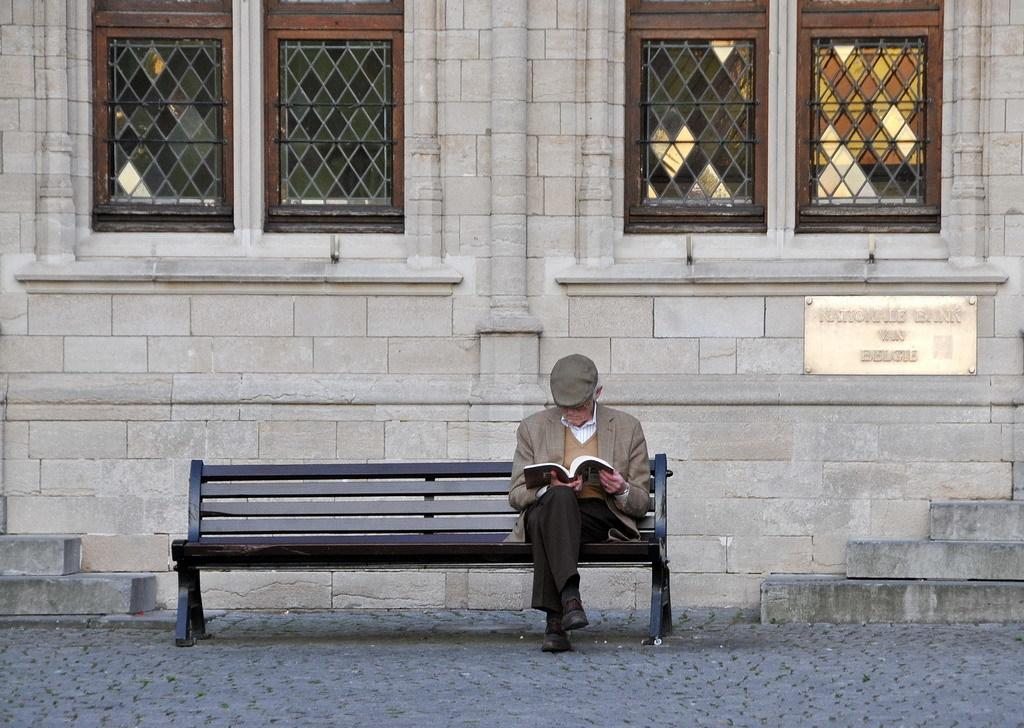Who is present in the image? There is a man in the image. What is the man doing in the image? The man is seated on a bench and reading a book. What can be seen in the background of the image? There is a building in the background of the image. Where is the lunchroom located in the image? There is no mention of a lunchroom in the image; it only features a man seated on a bench reading a book with a building in the background. 